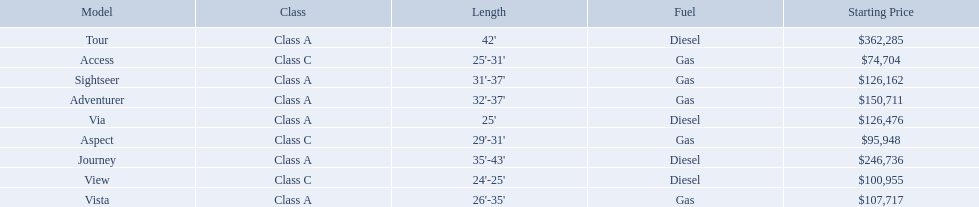Which of the models in the table use diesel fuel? Tour, Journey, Via, View. Of these models, which are class a? Tour, Journey, Via. Which of them are greater than 35' in length? Tour, Journey. Which of the two models is more expensive? Tour. What are the prices? $362,285, $246,736, $150,711, $126,476, $126,162, $107,717, $100,955, $95,948, $74,704. What is the top price? $362,285. What model has this price? Tour. What are all of the winnebago models? Tour, Journey, Adventurer, Via, Sightseer, Vista, View, Aspect, Access. What are their prices? $362,285, $246,736, $150,711, $126,476, $126,162, $107,717, $100,955, $95,948, $74,704. And which model costs the most? Tour. 